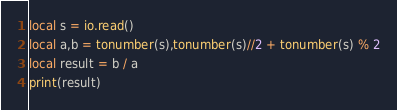Convert code to text. <code><loc_0><loc_0><loc_500><loc_500><_Lua_>local s = io.read()
local a,b = tonumber(s),tonumber(s)//2 + tonumber(s) % 2
local result = b / a
print(result)</code> 